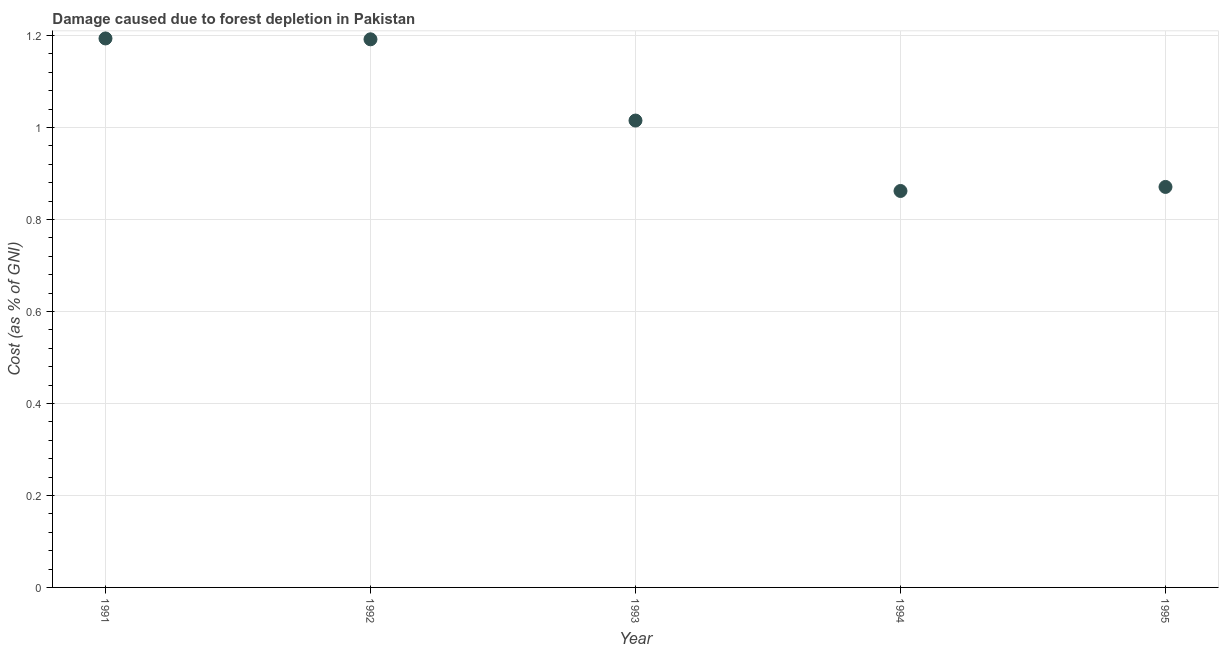What is the damage caused due to forest depletion in 1994?
Offer a terse response. 0.86. Across all years, what is the maximum damage caused due to forest depletion?
Keep it short and to the point. 1.19. Across all years, what is the minimum damage caused due to forest depletion?
Make the answer very short. 0.86. In which year was the damage caused due to forest depletion maximum?
Offer a terse response. 1991. In which year was the damage caused due to forest depletion minimum?
Your answer should be compact. 1994. What is the sum of the damage caused due to forest depletion?
Your response must be concise. 5.13. What is the difference between the damage caused due to forest depletion in 1994 and 1995?
Give a very brief answer. -0.01. What is the average damage caused due to forest depletion per year?
Your answer should be very brief. 1.03. What is the median damage caused due to forest depletion?
Provide a succinct answer. 1.02. Do a majority of the years between 1993 and 1995 (inclusive) have damage caused due to forest depletion greater than 0.52 %?
Give a very brief answer. Yes. What is the ratio of the damage caused due to forest depletion in 1992 to that in 1993?
Offer a very short reply. 1.17. Is the damage caused due to forest depletion in 1991 less than that in 1994?
Your response must be concise. No. What is the difference between the highest and the second highest damage caused due to forest depletion?
Give a very brief answer. 0. What is the difference between the highest and the lowest damage caused due to forest depletion?
Your response must be concise. 0.33. Does the damage caused due to forest depletion monotonically increase over the years?
Offer a very short reply. No. How many years are there in the graph?
Keep it short and to the point. 5. Are the values on the major ticks of Y-axis written in scientific E-notation?
Keep it short and to the point. No. Does the graph contain any zero values?
Your response must be concise. No. What is the title of the graph?
Offer a very short reply. Damage caused due to forest depletion in Pakistan. What is the label or title of the Y-axis?
Ensure brevity in your answer.  Cost (as % of GNI). What is the Cost (as % of GNI) in 1991?
Offer a very short reply. 1.19. What is the Cost (as % of GNI) in 1992?
Provide a succinct answer. 1.19. What is the Cost (as % of GNI) in 1993?
Your response must be concise. 1.02. What is the Cost (as % of GNI) in 1994?
Offer a very short reply. 0.86. What is the Cost (as % of GNI) in 1995?
Give a very brief answer. 0.87. What is the difference between the Cost (as % of GNI) in 1991 and 1992?
Offer a terse response. 0. What is the difference between the Cost (as % of GNI) in 1991 and 1993?
Make the answer very short. 0.18. What is the difference between the Cost (as % of GNI) in 1991 and 1994?
Keep it short and to the point. 0.33. What is the difference between the Cost (as % of GNI) in 1991 and 1995?
Ensure brevity in your answer.  0.32. What is the difference between the Cost (as % of GNI) in 1992 and 1993?
Provide a succinct answer. 0.18. What is the difference between the Cost (as % of GNI) in 1992 and 1994?
Give a very brief answer. 0.33. What is the difference between the Cost (as % of GNI) in 1992 and 1995?
Make the answer very short. 0.32. What is the difference between the Cost (as % of GNI) in 1993 and 1994?
Ensure brevity in your answer.  0.15. What is the difference between the Cost (as % of GNI) in 1993 and 1995?
Your answer should be very brief. 0.14. What is the difference between the Cost (as % of GNI) in 1994 and 1995?
Offer a terse response. -0.01. What is the ratio of the Cost (as % of GNI) in 1991 to that in 1992?
Make the answer very short. 1. What is the ratio of the Cost (as % of GNI) in 1991 to that in 1993?
Offer a very short reply. 1.18. What is the ratio of the Cost (as % of GNI) in 1991 to that in 1994?
Your response must be concise. 1.39. What is the ratio of the Cost (as % of GNI) in 1991 to that in 1995?
Offer a very short reply. 1.37. What is the ratio of the Cost (as % of GNI) in 1992 to that in 1993?
Provide a succinct answer. 1.17. What is the ratio of the Cost (as % of GNI) in 1992 to that in 1994?
Your answer should be compact. 1.38. What is the ratio of the Cost (as % of GNI) in 1992 to that in 1995?
Your response must be concise. 1.37. What is the ratio of the Cost (as % of GNI) in 1993 to that in 1994?
Make the answer very short. 1.18. What is the ratio of the Cost (as % of GNI) in 1993 to that in 1995?
Make the answer very short. 1.17. What is the ratio of the Cost (as % of GNI) in 1994 to that in 1995?
Ensure brevity in your answer.  0.99. 